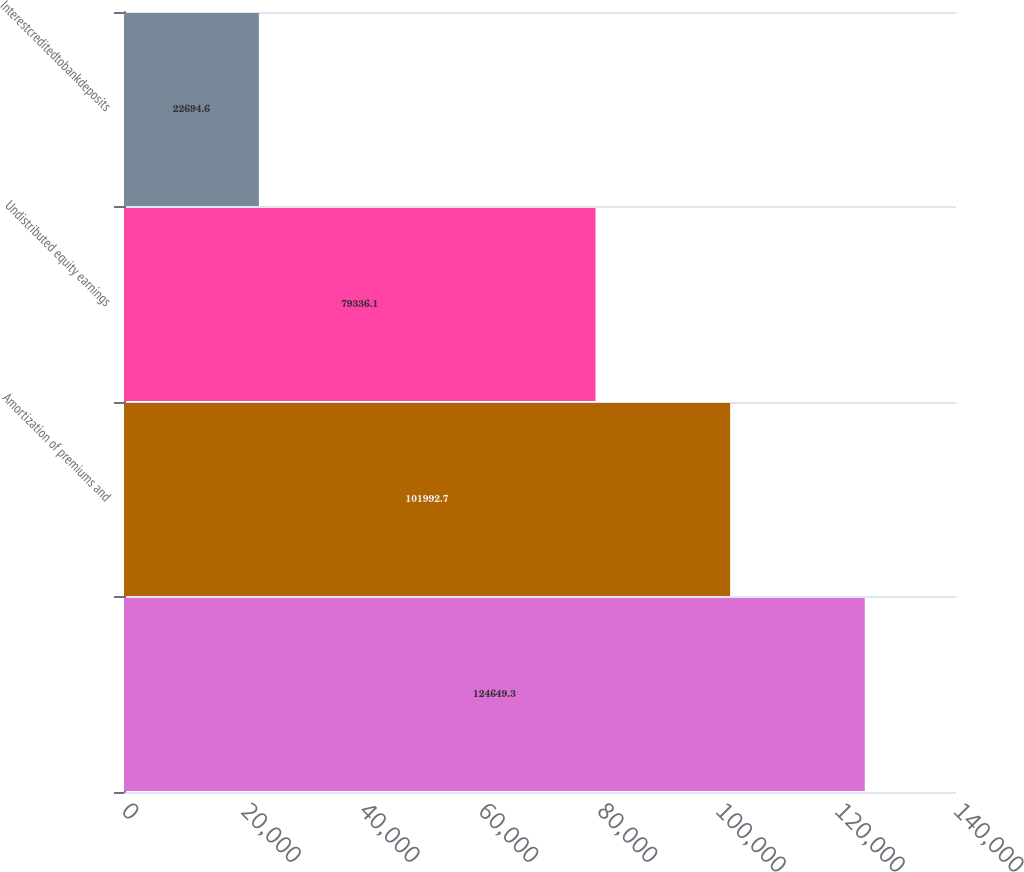<chart> <loc_0><loc_0><loc_500><loc_500><bar_chart><ecel><fcel>Amortization of premiums and<fcel>Undistributed equity earnings<fcel>Interestcreditedtobankdeposits<nl><fcel>124649<fcel>101993<fcel>79336.1<fcel>22694.6<nl></chart> 